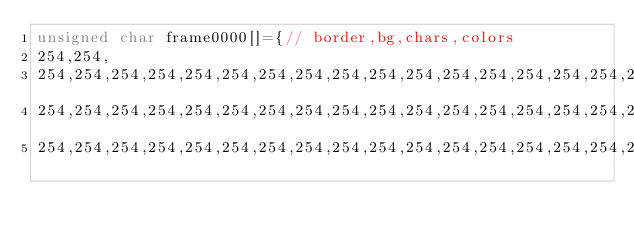<code> <loc_0><loc_0><loc_500><loc_500><_C_>unsigned char frame0000[]={// border,bg,chars,colors
254,254,
254,254,254,254,254,254,254,254,254,254,254,254,254,254,254,254,254,254,254,254,254,254,254,254,254,254,254,254,254,254,254,254,254,254,254,254,254,254,254,254,
254,254,254,254,254,254,254,254,254,254,254,254,254,254,254,254,254,254,254,254,254,254,254,254,254,254,254,254,254,254,254,254,254,254,254,254,254,254,254,254,
254,254,254,254,254,254,254,254,254,254,254,254,254,254,254,254,254,254,254,254,254,254,254,254,254,254,254,254,254,254,254,254,254,254,254,254,254,254,254,254,</code> 